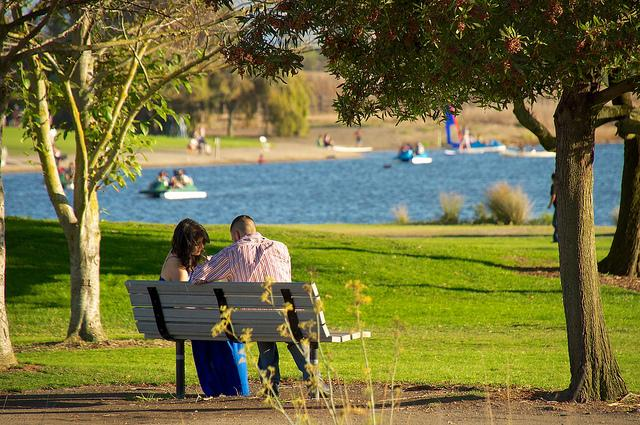What is rented for family enjoyment?

Choices:
A) scuba gear
B) boats
C) benches
D) kites boats 